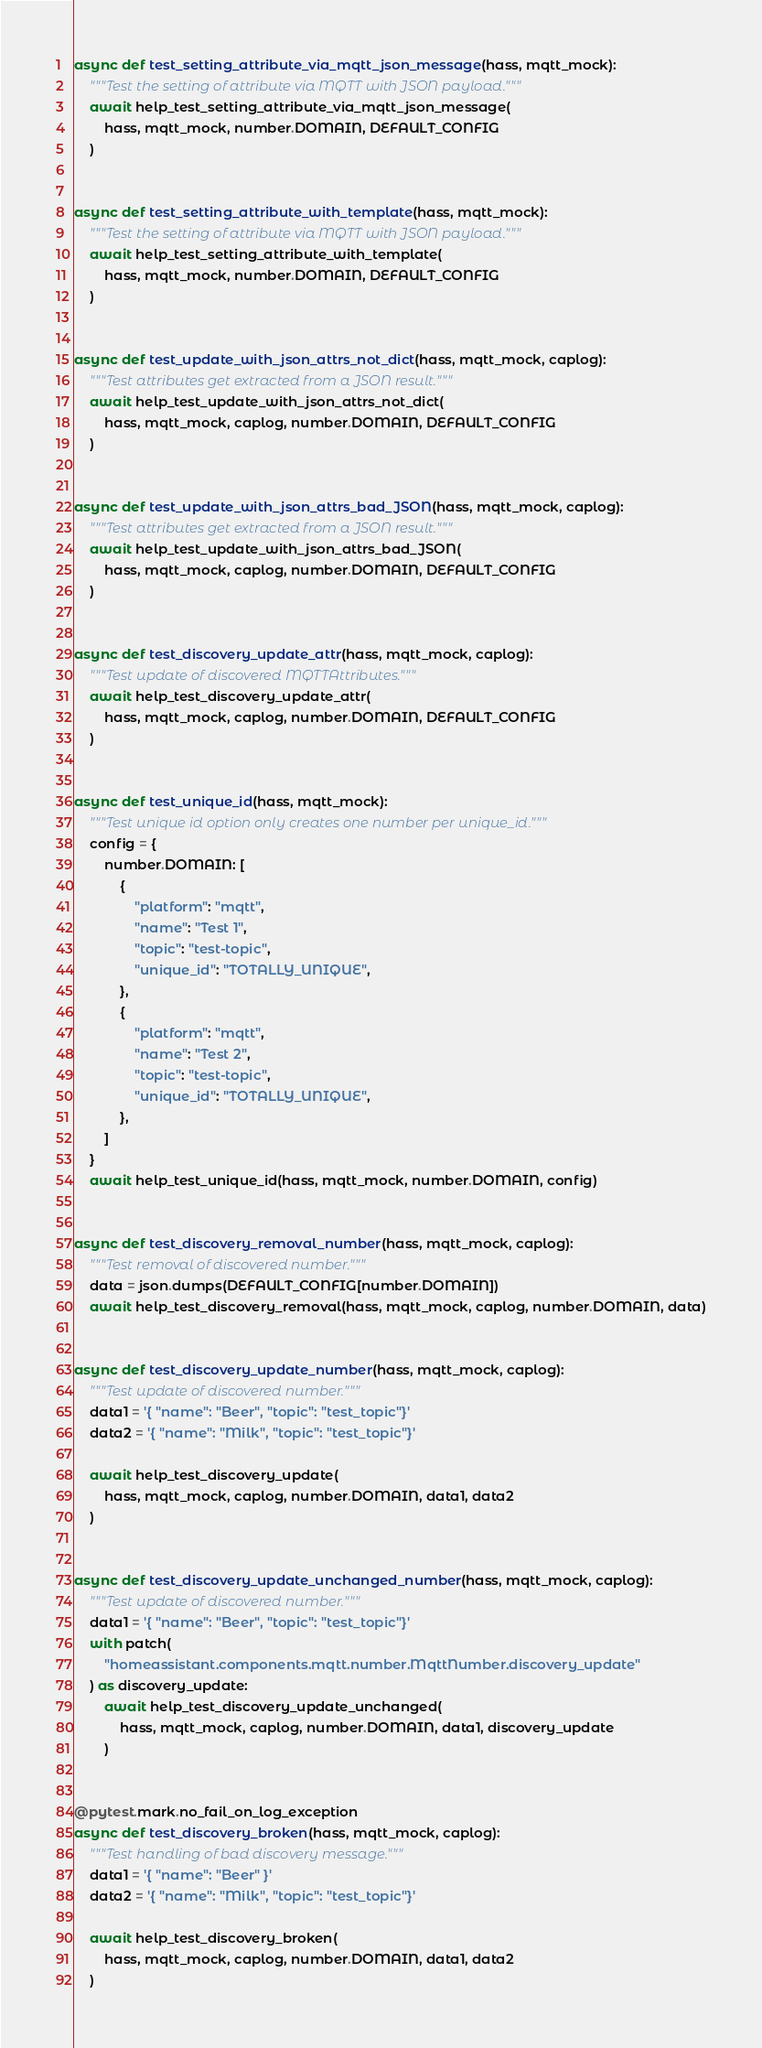Convert code to text. <code><loc_0><loc_0><loc_500><loc_500><_Python_>async def test_setting_attribute_via_mqtt_json_message(hass, mqtt_mock):
    """Test the setting of attribute via MQTT with JSON payload."""
    await help_test_setting_attribute_via_mqtt_json_message(
        hass, mqtt_mock, number.DOMAIN, DEFAULT_CONFIG
    )


async def test_setting_attribute_with_template(hass, mqtt_mock):
    """Test the setting of attribute via MQTT with JSON payload."""
    await help_test_setting_attribute_with_template(
        hass, mqtt_mock, number.DOMAIN, DEFAULT_CONFIG
    )


async def test_update_with_json_attrs_not_dict(hass, mqtt_mock, caplog):
    """Test attributes get extracted from a JSON result."""
    await help_test_update_with_json_attrs_not_dict(
        hass, mqtt_mock, caplog, number.DOMAIN, DEFAULT_CONFIG
    )


async def test_update_with_json_attrs_bad_JSON(hass, mqtt_mock, caplog):
    """Test attributes get extracted from a JSON result."""
    await help_test_update_with_json_attrs_bad_JSON(
        hass, mqtt_mock, caplog, number.DOMAIN, DEFAULT_CONFIG
    )


async def test_discovery_update_attr(hass, mqtt_mock, caplog):
    """Test update of discovered MQTTAttributes."""
    await help_test_discovery_update_attr(
        hass, mqtt_mock, caplog, number.DOMAIN, DEFAULT_CONFIG
    )


async def test_unique_id(hass, mqtt_mock):
    """Test unique id option only creates one number per unique_id."""
    config = {
        number.DOMAIN: [
            {
                "platform": "mqtt",
                "name": "Test 1",
                "topic": "test-topic",
                "unique_id": "TOTALLY_UNIQUE",
            },
            {
                "platform": "mqtt",
                "name": "Test 2",
                "topic": "test-topic",
                "unique_id": "TOTALLY_UNIQUE",
            },
        ]
    }
    await help_test_unique_id(hass, mqtt_mock, number.DOMAIN, config)


async def test_discovery_removal_number(hass, mqtt_mock, caplog):
    """Test removal of discovered number."""
    data = json.dumps(DEFAULT_CONFIG[number.DOMAIN])
    await help_test_discovery_removal(hass, mqtt_mock, caplog, number.DOMAIN, data)


async def test_discovery_update_number(hass, mqtt_mock, caplog):
    """Test update of discovered number."""
    data1 = '{ "name": "Beer", "topic": "test_topic"}'
    data2 = '{ "name": "Milk", "topic": "test_topic"}'

    await help_test_discovery_update(
        hass, mqtt_mock, caplog, number.DOMAIN, data1, data2
    )


async def test_discovery_update_unchanged_number(hass, mqtt_mock, caplog):
    """Test update of discovered number."""
    data1 = '{ "name": "Beer", "topic": "test_topic"}'
    with patch(
        "homeassistant.components.mqtt.number.MqttNumber.discovery_update"
    ) as discovery_update:
        await help_test_discovery_update_unchanged(
            hass, mqtt_mock, caplog, number.DOMAIN, data1, discovery_update
        )


@pytest.mark.no_fail_on_log_exception
async def test_discovery_broken(hass, mqtt_mock, caplog):
    """Test handling of bad discovery message."""
    data1 = '{ "name": "Beer" }'
    data2 = '{ "name": "Milk", "topic": "test_topic"}'

    await help_test_discovery_broken(
        hass, mqtt_mock, caplog, number.DOMAIN, data1, data2
    )

</code> 